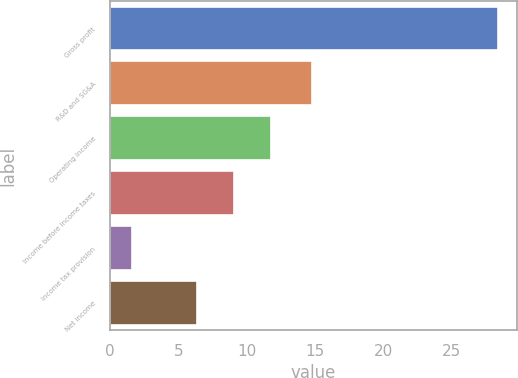Convert chart to OTSL. <chart><loc_0><loc_0><loc_500><loc_500><bar_chart><fcel>Gross profit<fcel>R&D and SG&A<fcel>Operating income<fcel>Income before income taxes<fcel>Income tax provision<fcel>Net income<nl><fcel>28.4<fcel>14.8<fcel>11.76<fcel>9.08<fcel>1.6<fcel>6.4<nl></chart> 